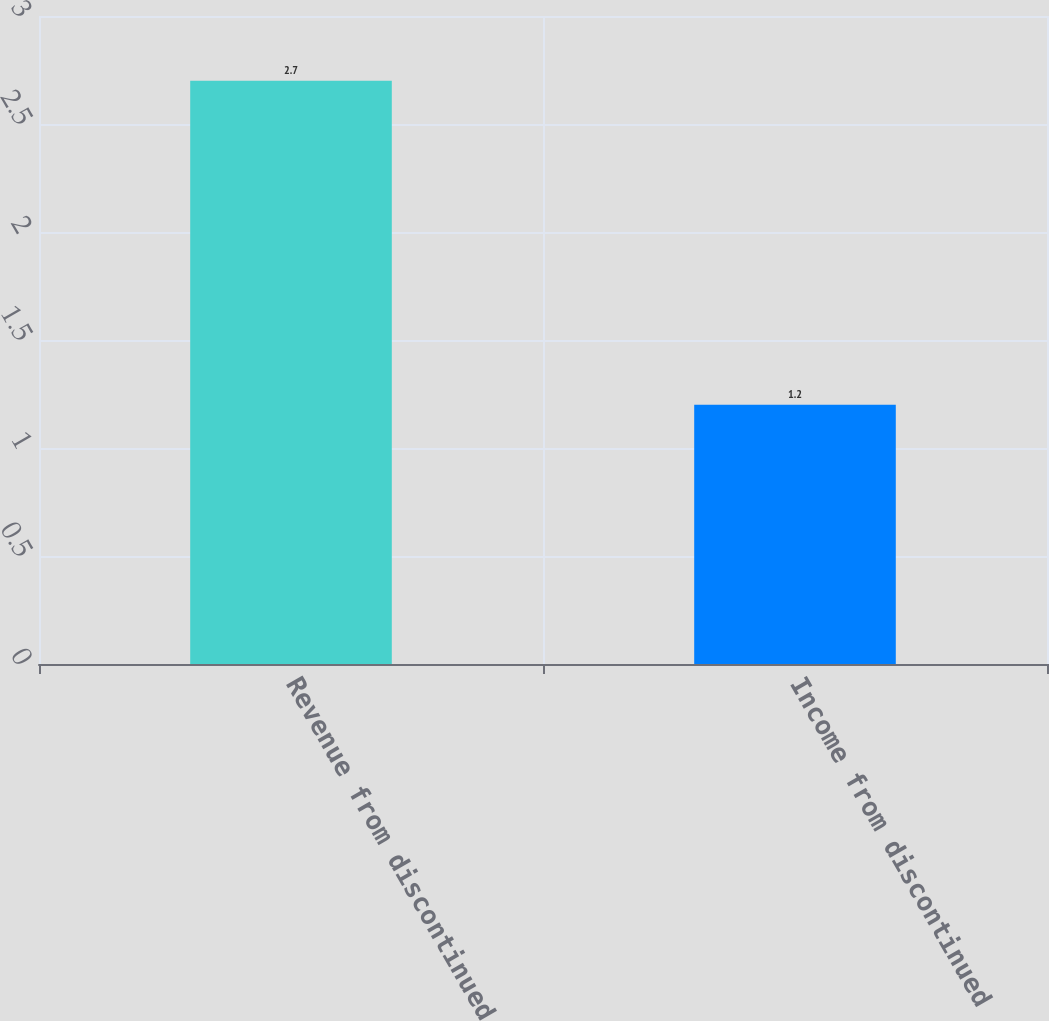Convert chart. <chart><loc_0><loc_0><loc_500><loc_500><bar_chart><fcel>Revenue from discontinued<fcel>Income from discontinued<nl><fcel>2.7<fcel>1.2<nl></chart> 